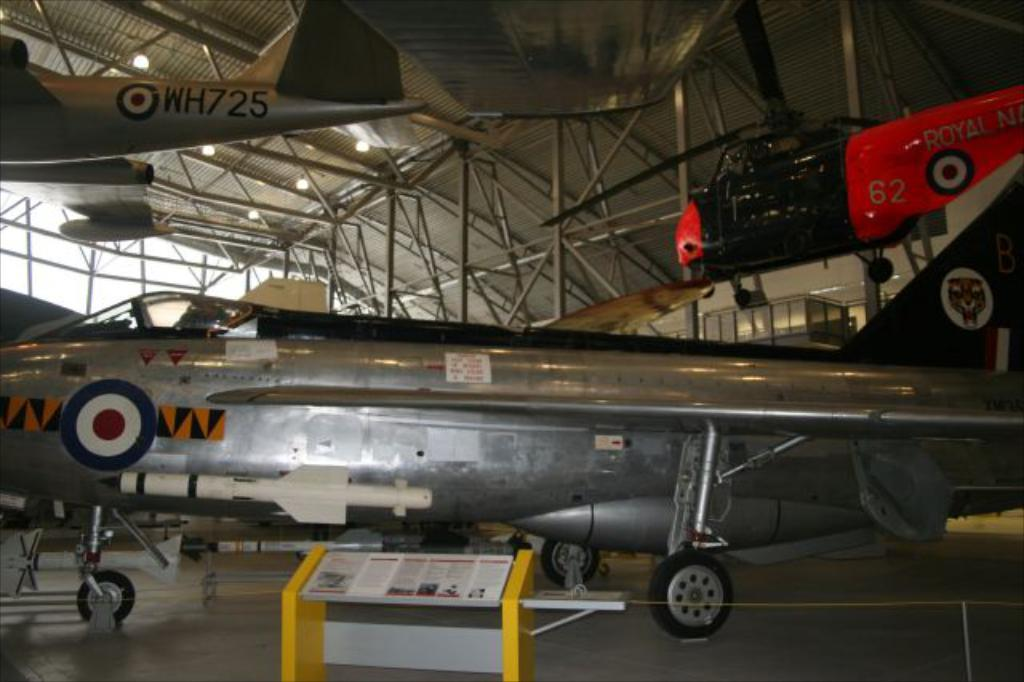<image>
Create a compact narrative representing the image presented. planes in a hanger with one above with the number 62 on it 